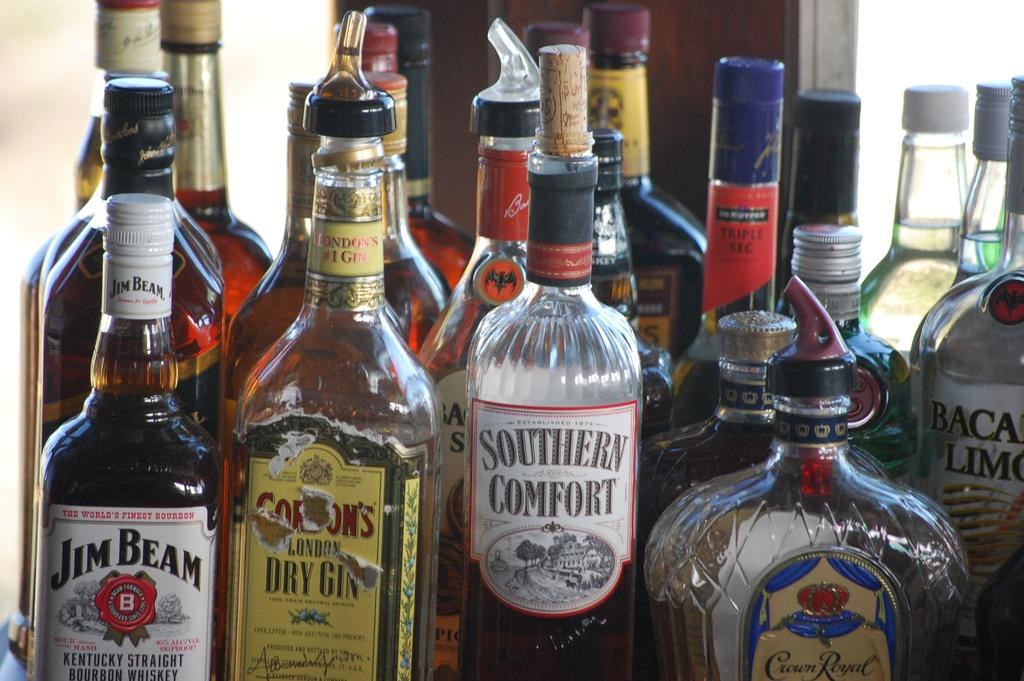<image>
Create a compact narrative representing the image presented. South Comfort alcohol bottle in between some other bottles. 